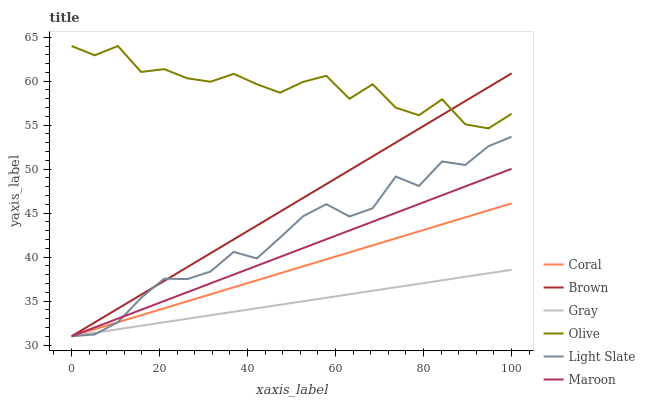Does Gray have the minimum area under the curve?
Answer yes or no. Yes. Does Olive have the maximum area under the curve?
Answer yes or no. Yes. Does Light Slate have the minimum area under the curve?
Answer yes or no. No. Does Light Slate have the maximum area under the curve?
Answer yes or no. No. Is Gray the smoothest?
Answer yes or no. Yes. Is Olive the roughest?
Answer yes or no. Yes. Is Light Slate the smoothest?
Answer yes or no. No. Is Light Slate the roughest?
Answer yes or no. No. Does Olive have the lowest value?
Answer yes or no. No. Does Light Slate have the highest value?
Answer yes or no. No. Is Maroon less than Olive?
Answer yes or no. Yes. Is Olive greater than Maroon?
Answer yes or no. Yes. Does Maroon intersect Olive?
Answer yes or no. No. 